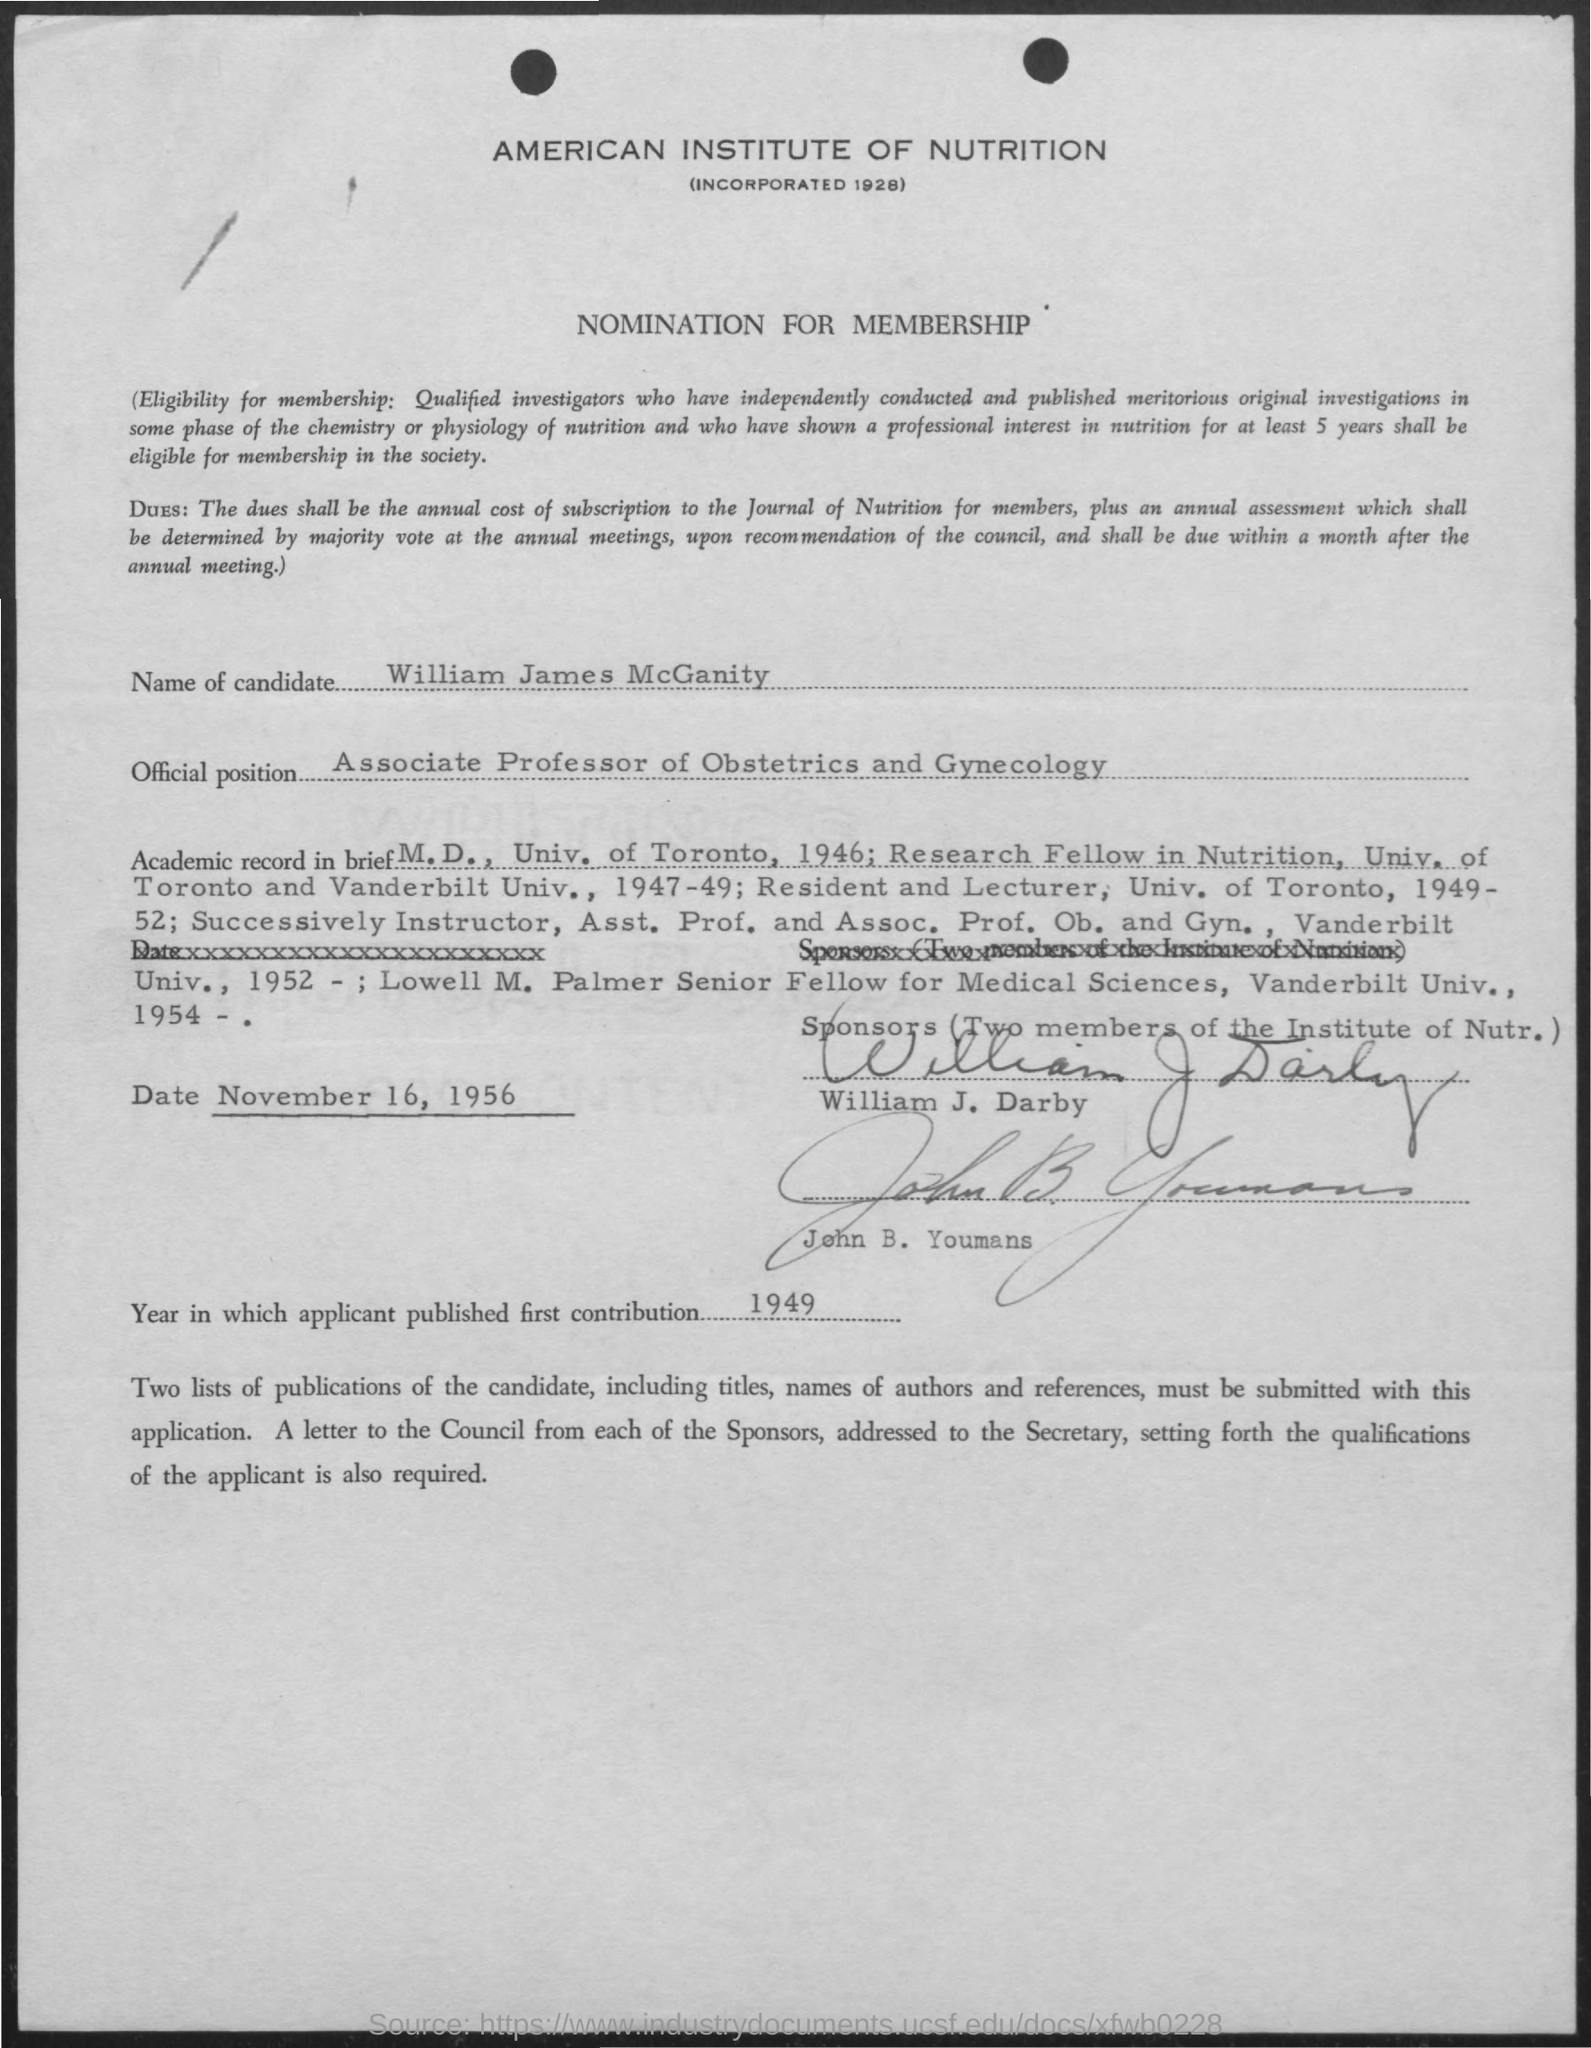List a handful of essential elements in this visual. The candidate's name is William James McGanity. The applicant first contributed in 1949... 